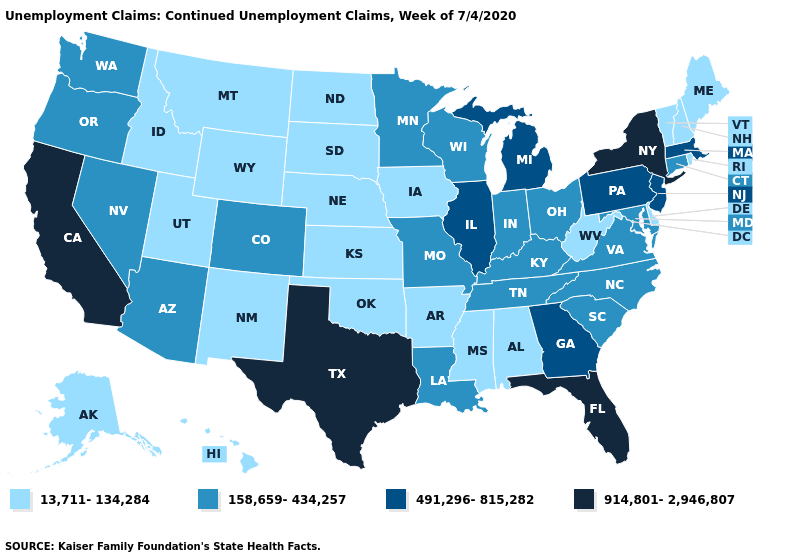Does the map have missing data?
Short answer required. No. What is the value of Florida?
Give a very brief answer. 914,801-2,946,807. Which states have the highest value in the USA?
Be succinct. California, Florida, New York, Texas. What is the value of Arizona?
Write a very short answer. 158,659-434,257. Name the states that have a value in the range 914,801-2,946,807?
Short answer required. California, Florida, New York, Texas. Name the states that have a value in the range 914,801-2,946,807?
Be succinct. California, Florida, New York, Texas. What is the value of Illinois?
Write a very short answer. 491,296-815,282. Does Kansas have the same value as Iowa?
Answer briefly. Yes. What is the value of Iowa?
Give a very brief answer. 13,711-134,284. Name the states that have a value in the range 158,659-434,257?
Be succinct. Arizona, Colorado, Connecticut, Indiana, Kentucky, Louisiana, Maryland, Minnesota, Missouri, Nevada, North Carolina, Ohio, Oregon, South Carolina, Tennessee, Virginia, Washington, Wisconsin. Among the states that border Idaho , which have the lowest value?
Concise answer only. Montana, Utah, Wyoming. What is the value of Vermont?
Short answer required. 13,711-134,284. Which states have the lowest value in the MidWest?
Answer briefly. Iowa, Kansas, Nebraska, North Dakota, South Dakota. Does Indiana have a higher value than Kansas?
Concise answer only. Yes. Name the states that have a value in the range 914,801-2,946,807?
Keep it brief. California, Florida, New York, Texas. 